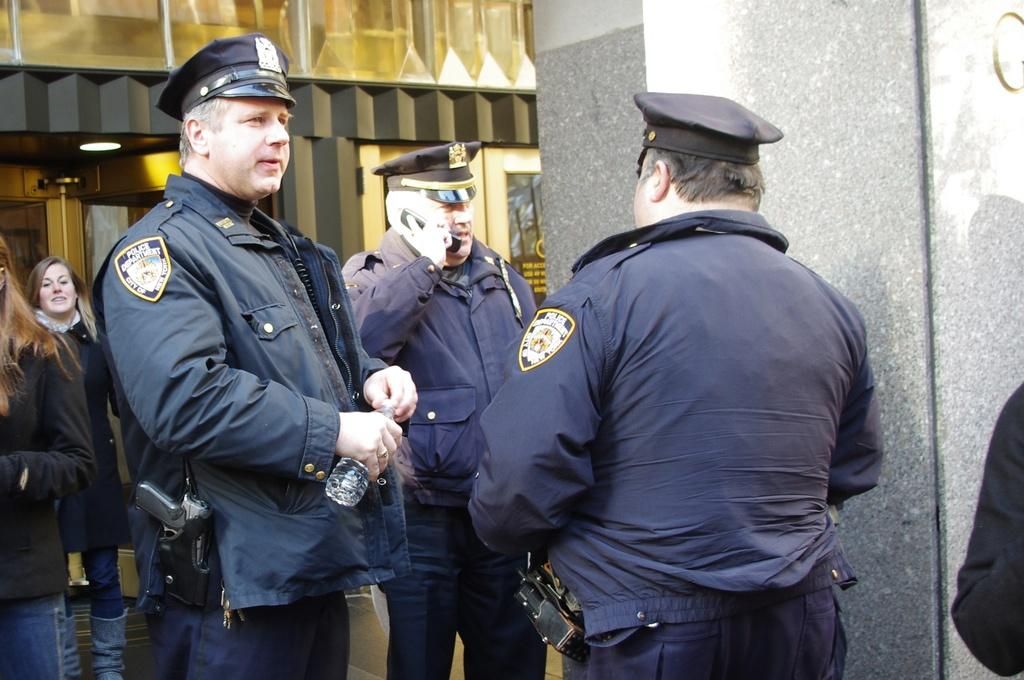What are the people in the image doing? The persons standing on the ground in the image are holding objects. What can be seen in the background of the image? There is a building and a wall in the background of the image. What type of nut is being used to hold the yoke in the image? There is no nut or yoke present in the image; it only features persons standing on the ground and holding objects, as well as a building and a wall in the background. 